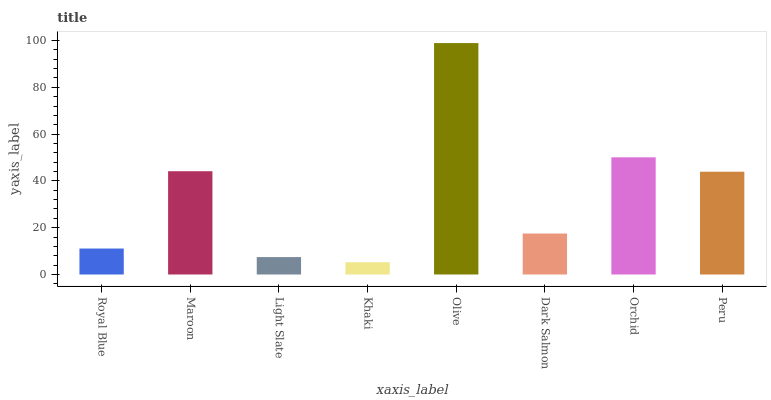Is Khaki the minimum?
Answer yes or no. Yes. Is Olive the maximum?
Answer yes or no. Yes. Is Maroon the minimum?
Answer yes or no. No. Is Maroon the maximum?
Answer yes or no. No. Is Maroon greater than Royal Blue?
Answer yes or no. Yes. Is Royal Blue less than Maroon?
Answer yes or no. Yes. Is Royal Blue greater than Maroon?
Answer yes or no. No. Is Maroon less than Royal Blue?
Answer yes or no. No. Is Peru the high median?
Answer yes or no. Yes. Is Dark Salmon the low median?
Answer yes or no. Yes. Is Olive the high median?
Answer yes or no. No. Is Peru the low median?
Answer yes or no. No. 